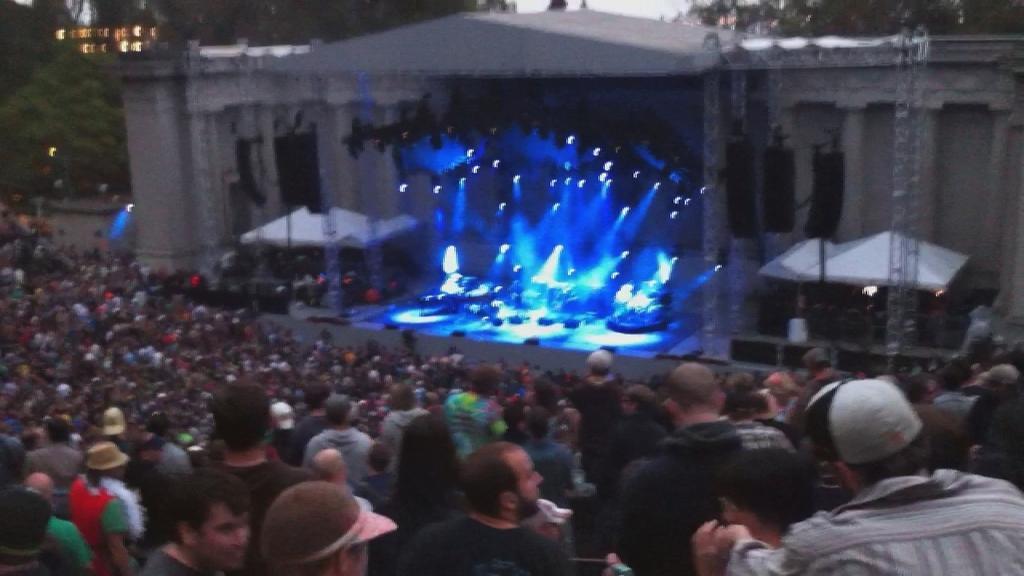How would you summarize this image in a sentence or two? In this image I can see at the bottom a group of people are there, in the middle there are lights on the stage, at the back side there are buildings. On the left side there are trees. 